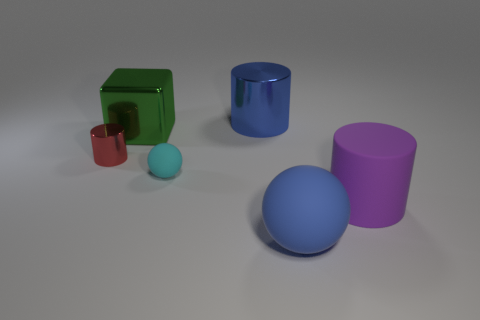Subtract all large matte cylinders. How many cylinders are left? 2 Add 2 blue rubber things. How many objects exist? 8 Subtract all red cylinders. How many cylinders are left? 2 Subtract all blocks. How many objects are left? 5 Add 2 cylinders. How many cylinders exist? 5 Subtract 0 purple blocks. How many objects are left? 6 Subtract 2 cylinders. How many cylinders are left? 1 Subtract all blue cubes. Subtract all blue spheres. How many cubes are left? 1 Subtract all large gray rubber things. Subtract all balls. How many objects are left? 4 Add 4 large matte objects. How many large matte objects are left? 6 